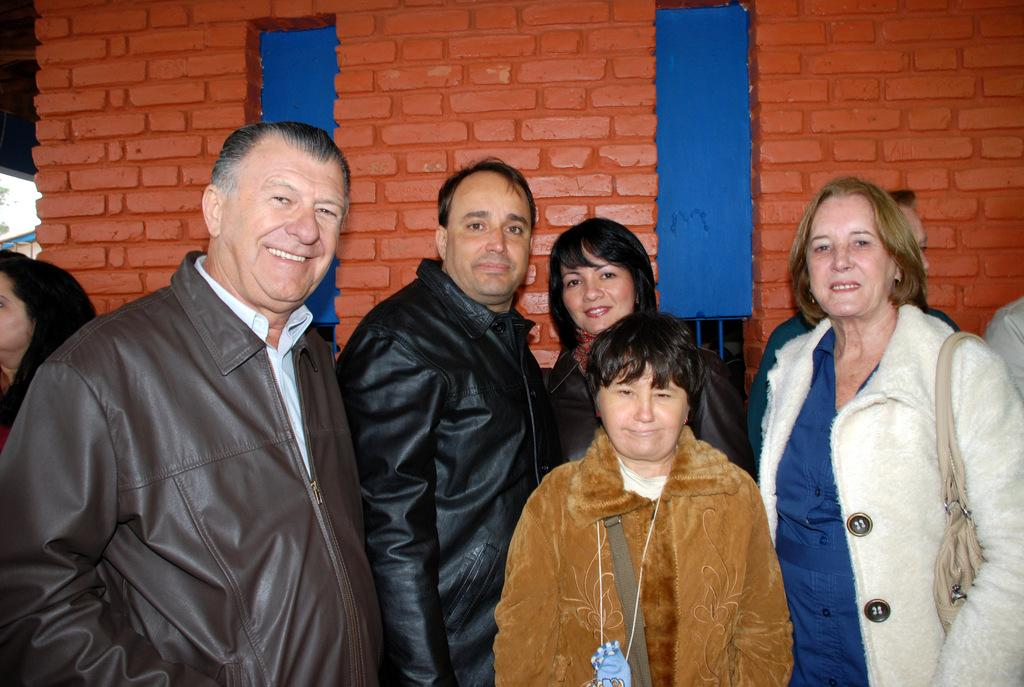How many people are in the image? There is a group of people in the image. What are the people doing in the image? The people are standing and smiling. What are the people looking at in the image? The people are looking at something, but it is not specified in the facts. What can be seen in the background of the image? There is a brick wall in the background of the image. What type of flower is growing on the glove of the person in the image? There is no flower or glove present in the image. What historical event is being commemorated in the image? The facts provided do not mention any historical event or context. 